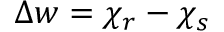<formula> <loc_0><loc_0><loc_500><loc_500>\Delta w = \chi _ { r } - \chi _ { s }</formula> 